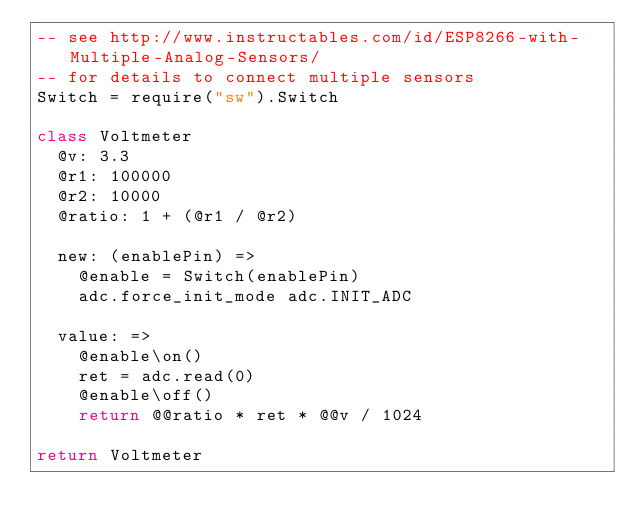<code> <loc_0><loc_0><loc_500><loc_500><_MoonScript_>-- see http://www.instructables.com/id/ESP8266-with-Multiple-Analog-Sensors/
-- for details to connect multiple sensors
Switch = require("sw").Switch

class Voltmeter
  @v: 3.3
  @r1: 100000
  @r2: 10000
  @ratio: 1 + (@r1 / @r2)

  new: (enablePin) =>
    @enable = Switch(enablePin)
    adc.force_init_mode adc.INIT_ADC

  value: =>
    @enable\on()
    ret = adc.read(0)
    @enable\off()
    return @@ratio * ret * @@v / 1024

return Voltmeter
</code> 